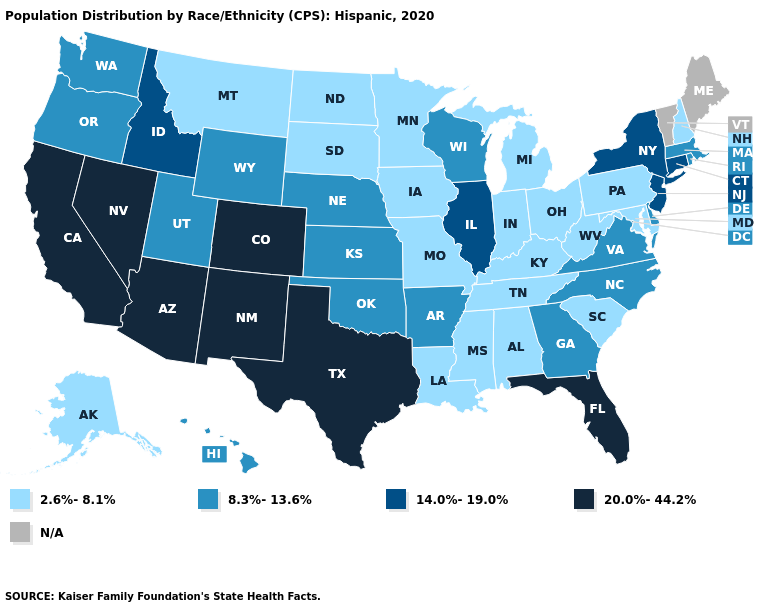Is the legend a continuous bar?
Be succinct. No. Name the states that have a value in the range 8.3%-13.6%?
Quick response, please. Arkansas, Delaware, Georgia, Hawaii, Kansas, Massachusetts, Nebraska, North Carolina, Oklahoma, Oregon, Rhode Island, Utah, Virginia, Washington, Wisconsin, Wyoming. What is the value of Oregon?
Short answer required. 8.3%-13.6%. What is the lowest value in states that border Arkansas?
Keep it brief. 2.6%-8.1%. What is the value of Washington?
Keep it brief. 8.3%-13.6%. Does Pennsylvania have the lowest value in the Northeast?
Keep it brief. Yes. Name the states that have a value in the range 2.6%-8.1%?
Answer briefly. Alabama, Alaska, Indiana, Iowa, Kentucky, Louisiana, Maryland, Michigan, Minnesota, Mississippi, Missouri, Montana, New Hampshire, North Dakota, Ohio, Pennsylvania, South Carolina, South Dakota, Tennessee, West Virginia. What is the highest value in the USA?
Be succinct. 20.0%-44.2%. How many symbols are there in the legend?
Answer briefly. 5. What is the value of Alaska?
Write a very short answer. 2.6%-8.1%. Does West Virginia have the highest value in the USA?
Concise answer only. No. What is the highest value in states that border Nevada?
Give a very brief answer. 20.0%-44.2%. Name the states that have a value in the range 8.3%-13.6%?
Give a very brief answer. Arkansas, Delaware, Georgia, Hawaii, Kansas, Massachusetts, Nebraska, North Carolina, Oklahoma, Oregon, Rhode Island, Utah, Virginia, Washington, Wisconsin, Wyoming. What is the value of Rhode Island?
Short answer required. 8.3%-13.6%. 